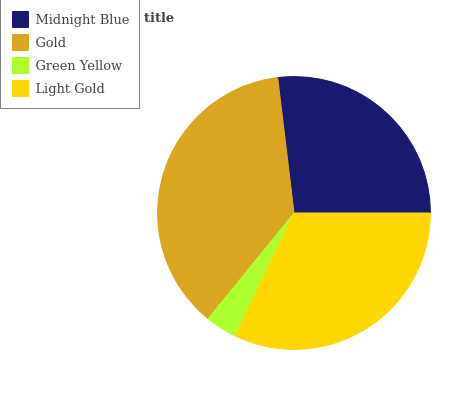Is Green Yellow the minimum?
Answer yes or no. Yes. Is Gold the maximum?
Answer yes or no. Yes. Is Gold the minimum?
Answer yes or no. No. Is Green Yellow the maximum?
Answer yes or no. No. Is Gold greater than Green Yellow?
Answer yes or no. Yes. Is Green Yellow less than Gold?
Answer yes or no. Yes. Is Green Yellow greater than Gold?
Answer yes or no. No. Is Gold less than Green Yellow?
Answer yes or no. No. Is Light Gold the high median?
Answer yes or no. Yes. Is Midnight Blue the low median?
Answer yes or no. Yes. Is Gold the high median?
Answer yes or no. No. Is Gold the low median?
Answer yes or no. No. 